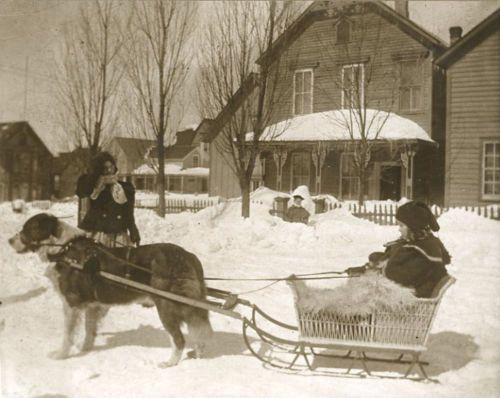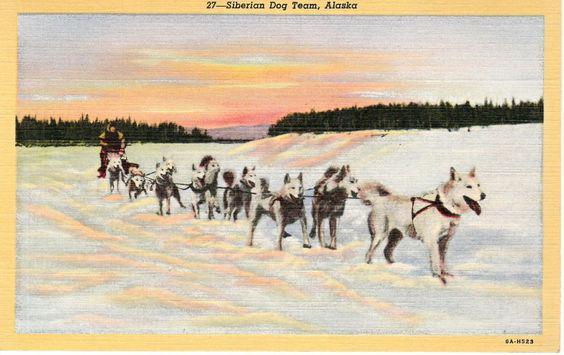The first image is the image on the left, the second image is the image on the right. Evaluate the accuracy of this statement regarding the images: "In the image to the right, the lead dog is a white husky.". Is it true? Answer yes or no. Yes. The first image is the image on the left, the second image is the image on the right. Considering the images on both sides, is "The left image contains only one sled, which is wooden and hitched to at least one leftward-turned dog with a person standing by the dog." valid? Answer yes or no. Yes. 